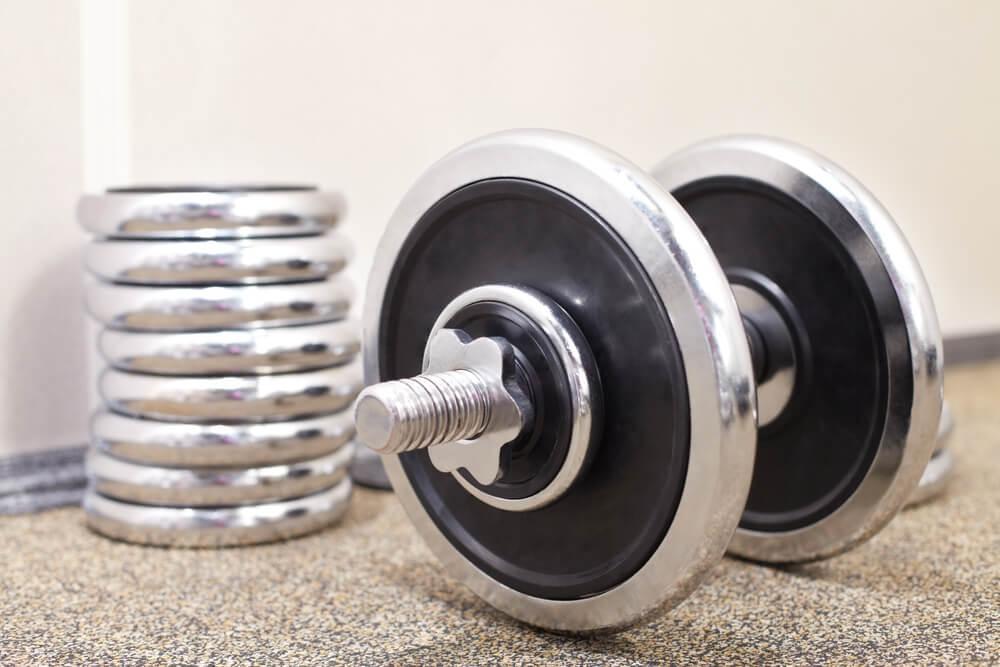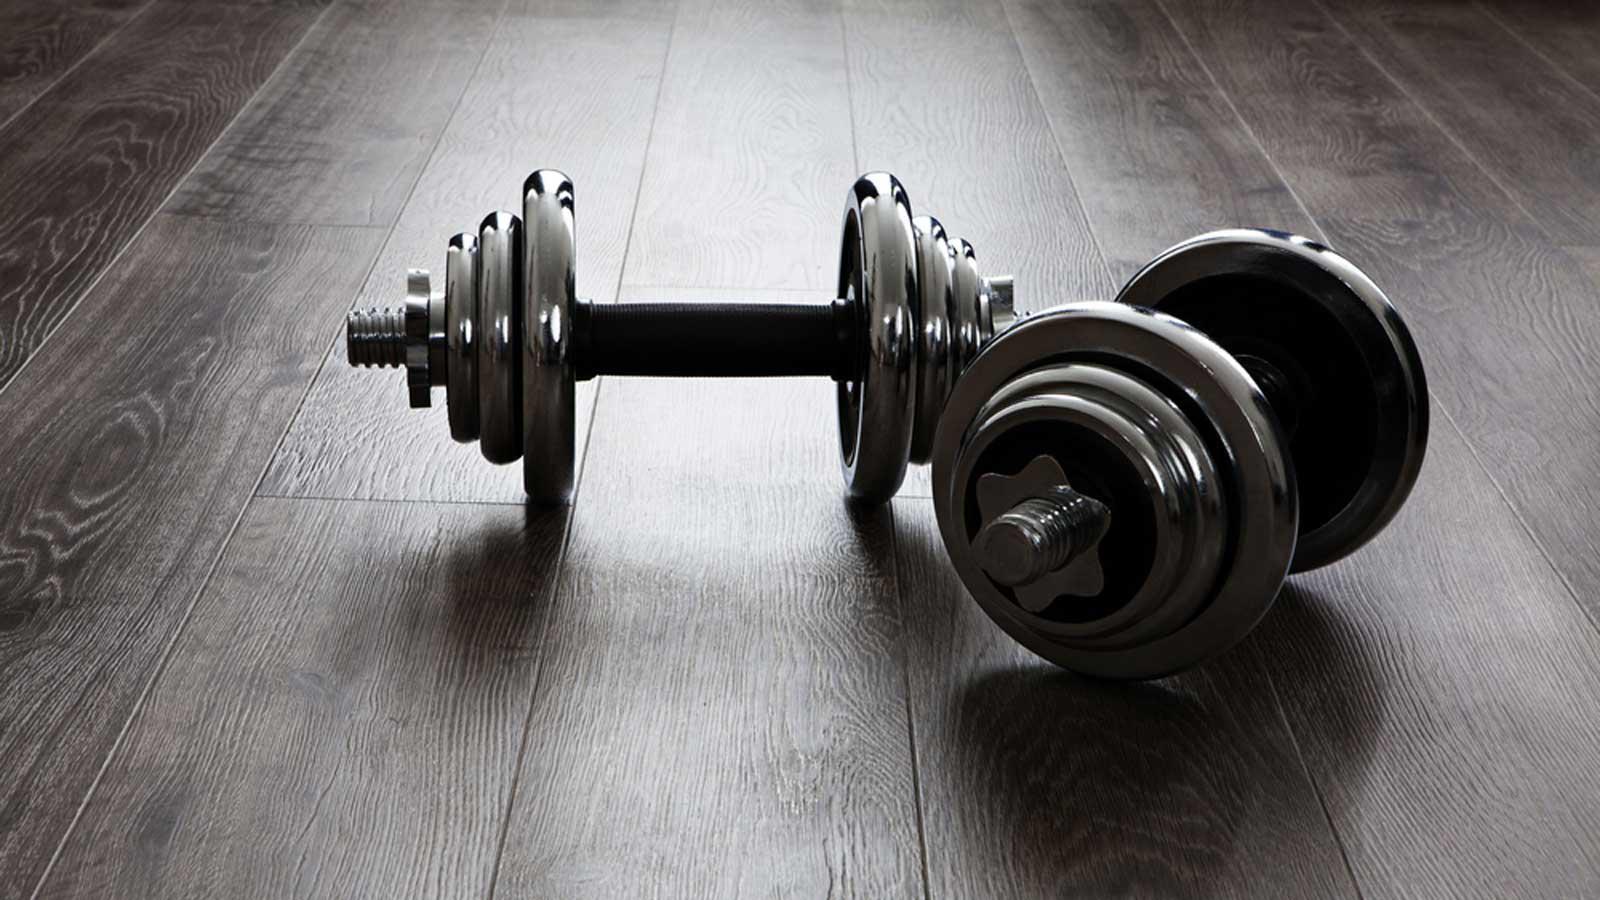The first image is the image on the left, the second image is the image on the right. Analyze the images presented: Is the assertion "In one of the images, there is an assembled dumbbell with extra plates next to it." valid? Answer yes or no. Yes. The first image is the image on the left, the second image is the image on the right. Considering the images on both sides, is "One image shows a row of at least four black barbells on a black rack." valid? Answer yes or no. No. 